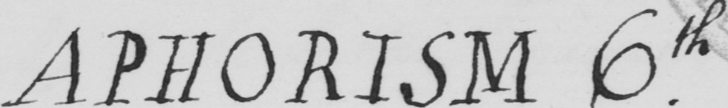Transcribe the text shown in this historical manuscript line. APHORISM 6th . 